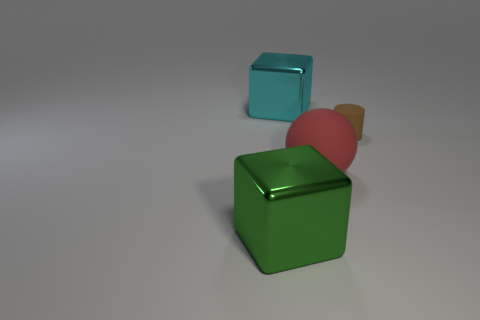Add 1 small yellow rubber spheres. How many objects exist? 5 Add 2 large green metallic cubes. How many large green metallic cubes exist? 3 Subtract 0 red cubes. How many objects are left? 4 Subtract all big rubber cylinders. Subtract all large cyan shiny things. How many objects are left? 3 Add 1 shiny things. How many shiny things are left? 3 